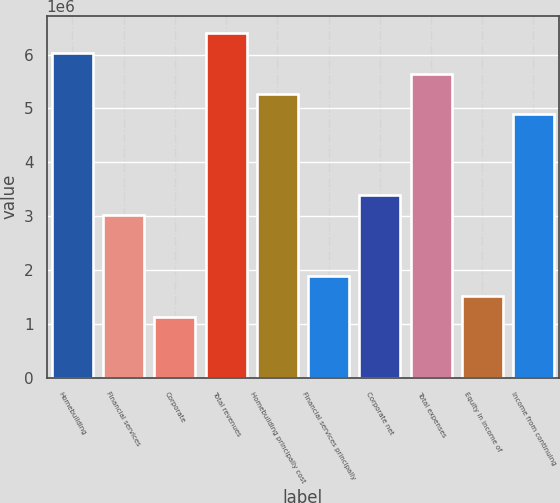<chart> <loc_0><loc_0><loc_500><loc_500><bar_chart><fcel>Homebuilding<fcel>Financial services<fcel>Corporate<fcel>Total revenues<fcel>Homebuilding principally cost<fcel>Financial services principally<fcel>Corporate net<fcel>Total expenses<fcel>Equity in income of<fcel>Income from continuing<nl><fcel>6.02211e+06<fcel>3.01105e+06<fcel>1.12915e+06<fcel>6.39849e+06<fcel>5.26934e+06<fcel>1.88191e+06<fcel>3.38744e+06<fcel>5.64573e+06<fcel>1.50553e+06<fcel>4.89296e+06<nl></chart> 